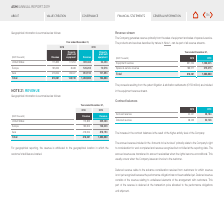According to Asm International Nv's financial document, How is revenue attributed in geographical reporting? attributed to the geographical location in which the customer’s facilities are located. The document states: "For geographical reporting, the revenue is attributed to the geographical location in which the customer’s facilities are located...." Also, What years does the table provide Geographical information for? The document shows two values: 2018 and 2019. From the document: "2018 2019 2018 2019..." Also, What are the regions presented in the table? The document contains multiple relevant values: United States, Europe, Asia. From the document: "Asia 476,624 89,027 818,194 101,894 Europe 165,602 8,468 126,203 10,516 United States 175,855 51,254 339,463 52,453..." Also, can you calculate: What was the percentage change in revenue from 2018 to 2019? To answer this question, I need to perform calculations using the financial data. The calculation is:  (1,283,860 - 818,081 )/ 818,081, which equals 56.94 (percentage). This is based on the information: "Total 818,081 148,749 1,283,860 164,863 Total 818,081 148,749 1,283,860 164,863..." The key data points involved are: 1,283,860, 818,081. Additionally, What are the regions ranked in descending order in terms of revenue for 2019? The document contains multiple relevant values: Asia, United States, Europe. From the document: "Europe 165,602 8,468 126,203 10,516 Asia 476,624 89,027 818,194 101,894 United States 175,855 51,254 339,463 52,453..." Additionally, Which region had the largest percentage change in revenue from 2018 to 2019? According to the financial document, United States. The relevant text states: "United States 175,855 51,254 339,463 52,453..." 